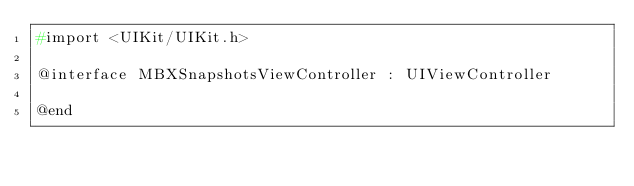<code> <loc_0><loc_0><loc_500><loc_500><_C_>#import <UIKit/UIKit.h>

@interface MBXSnapshotsViewController : UIViewController

@end
</code> 